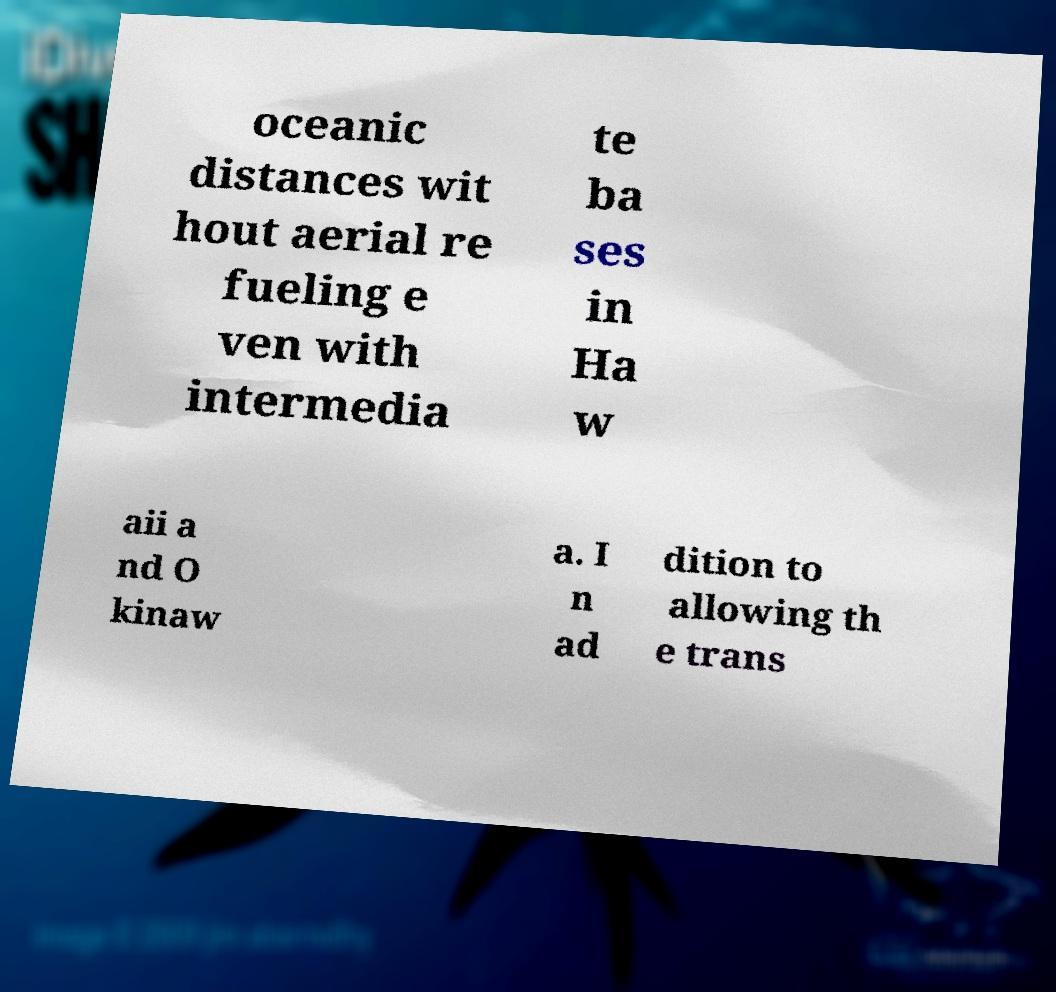There's text embedded in this image that I need extracted. Can you transcribe it verbatim? oceanic distances wit hout aerial re fueling e ven with intermedia te ba ses in Ha w aii a nd O kinaw a. I n ad dition to allowing th e trans 